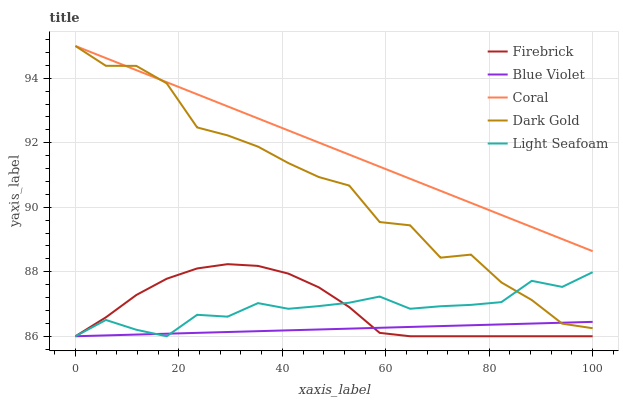Does Light Seafoam have the minimum area under the curve?
Answer yes or no. No. Does Light Seafoam have the maximum area under the curve?
Answer yes or no. No. Is Light Seafoam the smoothest?
Answer yes or no. No. Is Light Seafoam the roughest?
Answer yes or no. No. Does Coral have the lowest value?
Answer yes or no. No. Does Light Seafoam have the highest value?
Answer yes or no. No. Is Firebrick less than Coral?
Answer yes or no. Yes. Is Coral greater than Light Seafoam?
Answer yes or no. Yes. Does Firebrick intersect Coral?
Answer yes or no. No. 